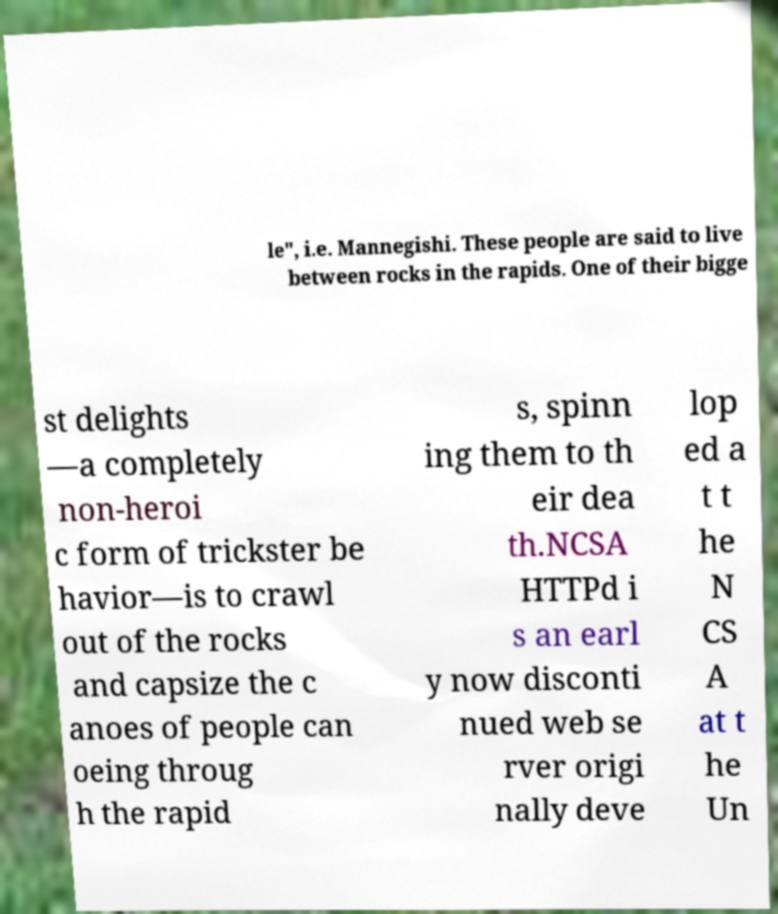What messages or text are displayed in this image? I need them in a readable, typed format. le", i.e. Mannegishi. These people are said to live between rocks in the rapids. One of their bigge st delights —a completely non-heroi c form of trickster be havior—is to crawl out of the rocks and capsize the c anoes of people can oeing throug h the rapid s, spinn ing them to th eir dea th.NCSA HTTPd i s an earl y now disconti nued web se rver origi nally deve lop ed a t t he N CS A at t he Un 